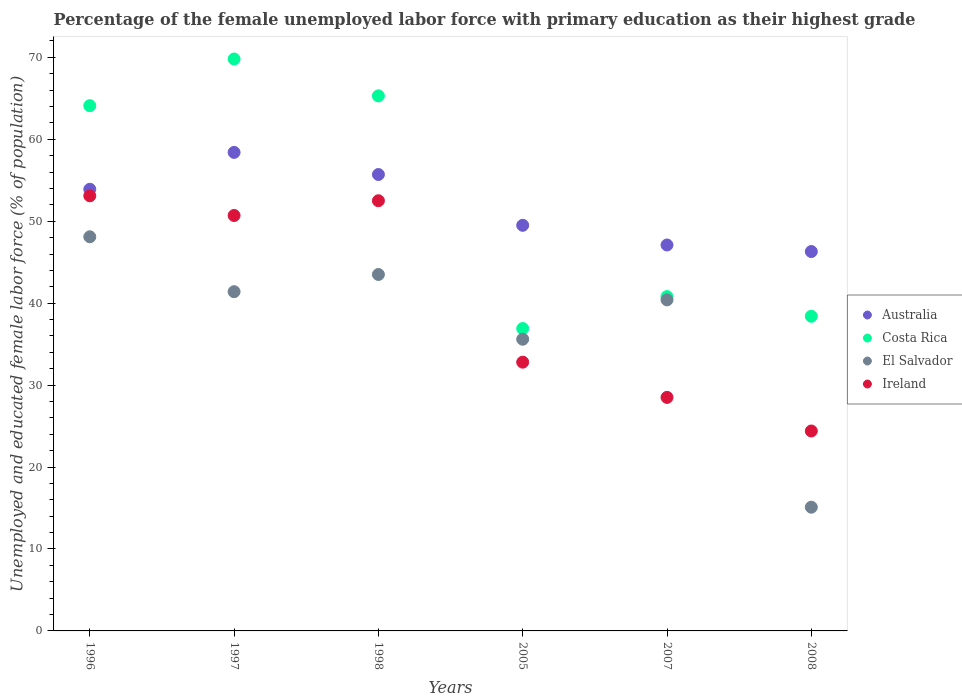How many different coloured dotlines are there?
Your response must be concise. 4. Is the number of dotlines equal to the number of legend labels?
Ensure brevity in your answer.  Yes. What is the percentage of the unemployed female labor force with primary education in El Salvador in 1997?
Your response must be concise. 41.4. Across all years, what is the maximum percentage of the unemployed female labor force with primary education in Costa Rica?
Keep it short and to the point. 69.8. Across all years, what is the minimum percentage of the unemployed female labor force with primary education in Ireland?
Your response must be concise. 24.4. In which year was the percentage of the unemployed female labor force with primary education in Costa Rica maximum?
Make the answer very short. 1997. What is the total percentage of the unemployed female labor force with primary education in Australia in the graph?
Your response must be concise. 310.9. What is the difference between the percentage of the unemployed female labor force with primary education in Ireland in 1997 and that in 2007?
Your answer should be very brief. 22.2. What is the difference between the percentage of the unemployed female labor force with primary education in Ireland in 1997 and the percentage of the unemployed female labor force with primary education in El Salvador in 2007?
Your answer should be very brief. 10.3. What is the average percentage of the unemployed female labor force with primary education in El Salvador per year?
Provide a succinct answer. 37.35. In the year 1997, what is the difference between the percentage of the unemployed female labor force with primary education in Ireland and percentage of the unemployed female labor force with primary education in Costa Rica?
Your answer should be compact. -19.1. In how many years, is the percentage of the unemployed female labor force with primary education in Australia greater than 32 %?
Give a very brief answer. 6. What is the ratio of the percentage of the unemployed female labor force with primary education in Ireland in 2007 to that in 2008?
Your answer should be compact. 1.17. Is the difference between the percentage of the unemployed female labor force with primary education in Ireland in 1998 and 2005 greater than the difference between the percentage of the unemployed female labor force with primary education in Costa Rica in 1998 and 2005?
Ensure brevity in your answer.  No. What is the difference between the highest and the second highest percentage of the unemployed female labor force with primary education in Australia?
Ensure brevity in your answer.  2.7. What is the difference between the highest and the lowest percentage of the unemployed female labor force with primary education in Australia?
Provide a succinct answer. 12.1. In how many years, is the percentage of the unemployed female labor force with primary education in Ireland greater than the average percentage of the unemployed female labor force with primary education in Ireland taken over all years?
Provide a succinct answer. 3. Is the sum of the percentage of the unemployed female labor force with primary education in Australia in 1996 and 1997 greater than the maximum percentage of the unemployed female labor force with primary education in Costa Rica across all years?
Make the answer very short. Yes. Is it the case that in every year, the sum of the percentage of the unemployed female labor force with primary education in Australia and percentage of the unemployed female labor force with primary education in El Salvador  is greater than the sum of percentage of the unemployed female labor force with primary education in Ireland and percentage of the unemployed female labor force with primary education in Costa Rica?
Your answer should be compact. No. Is it the case that in every year, the sum of the percentage of the unemployed female labor force with primary education in El Salvador and percentage of the unemployed female labor force with primary education in Australia  is greater than the percentage of the unemployed female labor force with primary education in Costa Rica?
Offer a terse response. Yes. Is the percentage of the unemployed female labor force with primary education in Australia strictly less than the percentage of the unemployed female labor force with primary education in Ireland over the years?
Give a very brief answer. No. How many years are there in the graph?
Give a very brief answer. 6. Are the values on the major ticks of Y-axis written in scientific E-notation?
Provide a succinct answer. No. How are the legend labels stacked?
Make the answer very short. Vertical. What is the title of the graph?
Keep it short and to the point. Percentage of the female unemployed labor force with primary education as their highest grade. Does "Sao Tome and Principe" appear as one of the legend labels in the graph?
Ensure brevity in your answer.  No. What is the label or title of the Y-axis?
Your answer should be compact. Unemployed and educated female labor force (% of population). What is the Unemployed and educated female labor force (% of population) of Australia in 1996?
Your response must be concise. 53.9. What is the Unemployed and educated female labor force (% of population) in Costa Rica in 1996?
Offer a terse response. 64.1. What is the Unemployed and educated female labor force (% of population) in El Salvador in 1996?
Keep it short and to the point. 48.1. What is the Unemployed and educated female labor force (% of population) of Ireland in 1996?
Ensure brevity in your answer.  53.1. What is the Unemployed and educated female labor force (% of population) of Australia in 1997?
Offer a very short reply. 58.4. What is the Unemployed and educated female labor force (% of population) of Costa Rica in 1997?
Offer a very short reply. 69.8. What is the Unemployed and educated female labor force (% of population) of El Salvador in 1997?
Ensure brevity in your answer.  41.4. What is the Unemployed and educated female labor force (% of population) in Ireland in 1997?
Make the answer very short. 50.7. What is the Unemployed and educated female labor force (% of population) of Australia in 1998?
Keep it short and to the point. 55.7. What is the Unemployed and educated female labor force (% of population) in Costa Rica in 1998?
Offer a terse response. 65.3. What is the Unemployed and educated female labor force (% of population) of El Salvador in 1998?
Offer a terse response. 43.5. What is the Unemployed and educated female labor force (% of population) in Ireland in 1998?
Make the answer very short. 52.5. What is the Unemployed and educated female labor force (% of population) of Australia in 2005?
Your answer should be very brief. 49.5. What is the Unemployed and educated female labor force (% of population) of Costa Rica in 2005?
Offer a terse response. 36.9. What is the Unemployed and educated female labor force (% of population) of El Salvador in 2005?
Provide a short and direct response. 35.6. What is the Unemployed and educated female labor force (% of population) in Ireland in 2005?
Give a very brief answer. 32.8. What is the Unemployed and educated female labor force (% of population) of Australia in 2007?
Make the answer very short. 47.1. What is the Unemployed and educated female labor force (% of population) in Costa Rica in 2007?
Your answer should be very brief. 40.8. What is the Unemployed and educated female labor force (% of population) in El Salvador in 2007?
Provide a succinct answer. 40.4. What is the Unemployed and educated female labor force (% of population) in Ireland in 2007?
Your response must be concise. 28.5. What is the Unemployed and educated female labor force (% of population) in Australia in 2008?
Give a very brief answer. 46.3. What is the Unemployed and educated female labor force (% of population) in Costa Rica in 2008?
Provide a short and direct response. 38.4. What is the Unemployed and educated female labor force (% of population) of El Salvador in 2008?
Your answer should be very brief. 15.1. What is the Unemployed and educated female labor force (% of population) in Ireland in 2008?
Your answer should be compact. 24.4. Across all years, what is the maximum Unemployed and educated female labor force (% of population) in Australia?
Your answer should be compact. 58.4. Across all years, what is the maximum Unemployed and educated female labor force (% of population) in Costa Rica?
Your response must be concise. 69.8. Across all years, what is the maximum Unemployed and educated female labor force (% of population) in El Salvador?
Make the answer very short. 48.1. Across all years, what is the maximum Unemployed and educated female labor force (% of population) in Ireland?
Your answer should be very brief. 53.1. Across all years, what is the minimum Unemployed and educated female labor force (% of population) of Australia?
Give a very brief answer. 46.3. Across all years, what is the minimum Unemployed and educated female labor force (% of population) of Costa Rica?
Provide a short and direct response. 36.9. Across all years, what is the minimum Unemployed and educated female labor force (% of population) of El Salvador?
Your response must be concise. 15.1. Across all years, what is the minimum Unemployed and educated female labor force (% of population) of Ireland?
Ensure brevity in your answer.  24.4. What is the total Unemployed and educated female labor force (% of population) in Australia in the graph?
Your response must be concise. 310.9. What is the total Unemployed and educated female labor force (% of population) in Costa Rica in the graph?
Keep it short and to the point. 315.3. What is the total Unemployed and educated female labor force (% of population) of El Salvador in the graph?
Provide a short and direct response. 224.1. What is the total Unemployed and educated female labor force (% of population) in Ireland in the graph?
Ensure brevity in your answer.  242. What is the difference between the Unemployed and educated female labor force (% of population) in Costa Rica in 1996 and that in 1997?
Your response must be concise. -5.7. What is the difference between the Unemployed and educated female labor force (% of population) of El Salvador in 1996 and that in 1997?
Offer a very short reply. 6.7. What is the difference between the Unemployed and educated female labor force (% of population) of Ireland in 1996 and that in 1997?
Provide a short and direct response. 2.4. What is the difference between the Unemployed and educated female labor force (% of population) in Costa Rica in 1996 and that in 2005?
Keep it short and to the point. 27.2. What is the difference between the Unemployed and educated female labor force (% of population) in El Salvador in 1996 and that in 2005?
Keep it short and to the point. 12.5. What is the difference between the Unemployed and educated female labor force (% of population) in Ireland in 1996 and that in 2005?
Your answer should be very brief. 20.3. What is the difference between the Unemployed and educated female labor force (% of population) of Australia in 1996 and that in 2007?
Ensure brevity in your answer.  6.8. What is the difference between the Unemployed and educated female labor force (% of population) in Costa Rica in 1996 and that in 2007?
Provide a short and direct response. 23.3. What is the difference between the Unemployed and educated female labor force (% of population) in El Salvador in 1996 and that in 2007?
Ensure brevity in your answer.  7.7. What is the difference between the Unemployed and educated female labor force (% of population) in Ireland in 1996 and that in 2007?
Your answer should be very brief. 24.6. What is the difference between the Unemployed and educated female labor force (% of population) of Costa Rica in 1996 and that in 2008?
Offer a terse response. 25.7. What is the difference between the Unemployed and educated female labor force (% of population) in El Salvador in 1996 and that in 2008?
Ensure brevity in your answer.  33. What is the difference between the Unemployed and educated female labor force (% of population) of Ireland in 1996 and that in 2008?
Keep it short and to the point. 28.7. What is the difference between the Unemployed and educated female labor force (% of population) in Costa Rica in 1997 and that in 1998?
Offer a terse response. 4.5. What is the difference between the Unemployed and educated female labor force (% of population) in El Salvador in 1997 and that in 1998?
Make the answer very short. -2.1. What is the difference between the Unemployed and educated female labor force (% of population) in Costa Rica in 1997 and that in 2005?
Offer a terse response. 32.9. What is the difference between the Unemployed and educated female labor force (% of population) in El Salvador in 1997 and that in 2005?
Provide a short and direct response. 5.8. What is the difference between the Unemployed and educated female labor force (% of population) of Ireland in 1997 and that in 2005?
Offer a terse response. 17.9. What is the difference between the Unemployed and educated female labor force (% of population) in Australia in 1997 and that in 2007?
Ensure brevity in your answer.  11.3. What is the difference between the Unemployed and educated female labor force (% of population) in Costa Rica in 1997 and that in 2007?
Your answer should be compact. 29. What is the difference between the Unemployed and educated female labor force (% of population) in El Salvador in 1997 and that in 2007?
Provide a short and direct response. 1. What is the difference between the Unemployed and educated female labor force (% of population) in Ireland in 1997 and that in 2007?
Your answer should be compact. 22.2. What is the difference between the Unemployed and educated female labor force (% of population) of Costa Rica in 1997 and that in 2008?
Keep it short and to the point. 31.4. What is the difference between the Unemployed and educated female labor force (% of population) of El Salvador in 1997 and that in 2008?
Offer a terse response. 26.3. What is the difference between the Unemployed and educated female labor force (% of population) in Ireland in 1997 and that in 2008?
Ensure brevity in your answer.  26.3. What is the difference between the Unemployed and educated female labor force (% of population) of Australia in 1998 and that in 2005?
Your answer should be compact. 6.2. What is the difference between the Unemployed and educated female labor force (% of population) of Costa Rica in 1998 and that in 2005?
Your answer should be very brief. 28.4. What is the difference between the Unemployed and educated female labor force (% of population) in Australia in 1998 and that in 2007?
Keep it short and to the point. 8.6. What is the difference between the Unemployed and educated female labor force (% of population) in El Salvador in 1998 and that in 2007?
Ensure brevity in your answer.  3.1. What is the difference between the Unemployed and educated female labor force (% of population) in Ireland in 1998 and that in 2007?
Make the answer very short. 24. What is the difference between the Unemployed and educated female labor force (% of population) of Costa Rica in 1998 and that in 2008?
Offer a terse response. 26.9. What is the difference between the Unemployed and educated female labor force (% of population) of El Salvador in 1998 and that in 2008?
Provide a short and direct response. 28.4. What is the difference between the Unemployed and educated female labor force (% of population) in Ireland in 1998 and that in 2008?
Ensure brevity in your answer.  28.1. What is the difference between the Unemployed and educated female labor force (% of population) in Australia in 2005 and that in 2007?
Make the answer very short. 2.4. What is the difference between the Unemployed and educated female labor force (% of population) in Australia in 2005 and that in 2008?
Offer a terse response. 3.2. What is the difference between the Unemployed and educated female labor force (% of population) in Costa Rica in 2005 and that in 2008?
Offer a terse response. -1.5. What is the difference between the Unemployed and educated female labor force (% of population) of El Salvador in 2005 and that in 2008?
Offer a terse response. 20.5. What is the difference between the Unemployed and educated female labor force (% of population) of El Salvador in 2007 and that in 2008?
Your response must be concise. 25.3. What is the difference between the Unemployed and educated female labor force (% of population) in Ireland in 2007 and that in 2008?
Your response must be concise. 4.1. What is the difference between the Unemployed and educated female labor force (% of population) of Australia in 1996 and the Unemployed and educated female labor force (% of population) of Costa Rica in 1997?
Provide a succinct answer. -15.9. What is the difference between the Unemployed and educated female labor force (% of population) in Australia in 1996 and the Unemployed and educated female labor force (% of population) in El Salvador in 1997?
Keep it short and to the point. 12.5. What is the difference between the Unemployed and educated female labor force (% of population) in Australia in 1996 and the Unemployed and educated female labor force (% of population) in Ireland in 1997?
Give a very brief answer. 3.2. What is the difference between the Unemployed and educated female labor force (% of population) in Costa Rica in 1996 and the Unemployed and educated female labor force (% of population) in El Salvador in 1997?
Give a very brief answer. 22.7. What is the difference between the Unemployed and educated female labor force (% of population) in Costa Rica in 1996 and the Unemployed and educated female labor force (% of population) in Ireland in 1997?
Make the answer very short. 13.4. What is the difference between the Unemployed and educated female labor force (% of population) in Australia in 1996 and the Unemployed and educated female labor force (% of population) in Costa Rica in 1998?
Keep it short and to the point. -11.4. What is the difference between the Unemployed and educated female labor force (% of population) in Australia in 1996 and the Unemployed and educated female labor force (% of population) in El Salvador in 1998?
Your response must be concise. 10.4. What is the difference between the Unemployed and educated female labor force (% of population) in Australia in 1996 and the Unemployed and educated female labor force (% of population) in Ireland in 1998?
Your answer should be very brief. 1.4. What is the difference between the Unemployed and educated female labor force (% of population) in Costa Rica in 1996 and the Unemployed and educated female labor force (% of population) in El Salvador in 1998?
Ensure brevity in your answer.  20.6. What is the difference between the Unemployed and educated female labor force (% of population) of Costa Rica in 1996 and the Unemployed and educated female labor force (% of population) of Ireland in 1998?
Offer a terse response. 11.6. What is the difference between the Unemployed and educated female labor force (% of population) in Australia in 1996 and the Unemployed and educated female labor force (% of population) in Ireland in 2005?
Give a very brief answer. 21.1. What is the difference between the Unemployed and educated female labor force (% of population) of Costa Rica in 1996 and the Unemployed and educated female labor force (% of population) of El Salvador in 2005?
Your answer should be compact. 28.5. What is the difference between the Unemployed and educated female labor force (% of population) in Costa Rica in 1996 and the Unemployed and educated female labor force (% of population) in Ireland in 2005?
Keep it short and to the point. 31.3. What is the difference between the Unemployed and educated female labor force (% of population) in Australia in 1996 and the Unemployed and educated female labor force (% of population) in El Salvador in 2007?
Provide a short and direct response. 13.5. What is the difference between the Unemployed and educated female labor force (% of population) of Australia in 1996 and the Unemployed and educated female labor force (% of population) of Ireland in 2007?
Ensure brevity in your answer.  25.4. What is the difference between the Unemployed and educated female labor force (% of population) in Costa Rica in 1996 and the Unemployed and educated female labor force (% of population) in El Salvador in 2007?
Provide a succinct answer. 23.7. What is the difference between the Unemployed and educated female labor force (% of population) in Costa Rica in 1996 and the Unemployed and educated female labor force (% of population) in Ireland in 2007?
Keep it short and to the point. 35.6. What is the difference between the Unemployed and educated female labor force (% of population) in El Salvador in 1996 and the Unemployed and educated female labor force (% of population) in Ireland in 2007?
Offer a terse response. 19.6. What is the difference between the Unemployed and educated female labor force (% of population) of Australia in 1996 and the Unemployed and educated female labor force (% of population) of El Salvador in 2008?
Your answer should be compact. 38.8. What is the difference between the Unemployed and educated female labor force (% of population) in Australia in 1996 and the Unemployed and educated female labor force (% of population) in Ireland in 2008?
Your answer should be compact. 29.5. What is the difference between the Unemployed and educated female labor force (% of population) of Costa Rica in 1996 and the Unemployed and educated female labor force (% of population) of El Salvador in 2008?
Offer a terse response. 49. What is the difference between the Unemployed and educated female labor force (% of population) of Costa Rica in 1996 and the Unemployed and educated female labor force (% of population) of Ireland in 2008?
Provide a succinct answer. 39.7. What is the difference between the Unemployed and educated female labor force (% of population) in El Salvador in 1996 and the Unemployed and educated female labor force (% of population) in Ireland in 2008?
Offer a very short reply. 23.7. What is the difference between the Unemployed and educated female labor force (% of population) in Australia in 1997 and the Unemployed and educated female labor force (% of population) in Costa Rica in 1998?
Ensure brevity in your answer.  -6.9. What is the difference between the Unemployed and educated female labor force (% of population) of Costa Rica in 1997 and the Unemployed and educated female labor force (% of population) of El Salvador in 1998?
Your answer should be very brief. 26.3. What is the difference between the Unemployed and educated female labor force (% of population) of Australia in 1997 and the Unemployed and educated female labor force (% of population) of El Salvador in 2005?
Give a very brief answer. 22.8. What is the difference between the Unemployed and educated female labor force (% of population) in Australia in 1997 and the Unemployed and educated female labor force (% of population) in Ireland in 2005?
Give a very brief answer. 25.6. What is the difference between the Unemployed and educated female labor force (% of population) of Costa Rica in 1997 and the Unemployed and educated female labor force (% of population) of El Salvador in 2005?
Your answer should be very brief. 34.2. What is the difference between the Unemployed and educated female labor force (% of population) in Australia in 1997 and the Unemployed and educated female labor force (% of population) in Ireland in 2007?
Give a very brief answer. 29.9. What is the difference between the Unemployed and educated female labor force (% of population) of Costa Rica in 1997 and the Unemployed and educated female labor force (% of population) of El Salvador in 2007?
Provide a short and direct response. 29.4. What is the difference between the Unemployed and educated female labor force (% of population) of Costa Rica in 1997 and the Unemployed and educated female labor force (% of population) of Ireland in 2007?
Your response must be concise. 41.3. What is the difference between the Unemployed and educated female labor force (% of population) in Australia in 1997 and the Unemployed and educated female labor force (% of population) in Costa Rica in 2008?
Offer a very short reply. 20. What is the difference between the Unemployed and educated female labor force (% of population) of Australia in 1997 and the Unemployed and educated female labor force (% of population) of El Salvador in 2008?
Give a very brief answer. 43.3. What is the difference between the Unemployed and educated female labor force (% of population) in Costa Rica in 1997 and the Unemployed and educated female labor force (% of population) in El Salvador in 2008?
Your answer should be very brief. 54.7. What is the difference between the Unemployed and educated female labor force (% of population) of Costa Rica in 1997 and the Unemployed and educated female labor force (% of population) of Ireland in 2008?
Offer a very short reply. 45.4. What is the difference between the Unemployed and educated female labor force (% of population) in El Salvador in 1997 and the Unemployed and educated female labor force (% of population) in Ireland in 2008?
Give a very brief answer. 17. What is the difference between the Unemployed and educated female labor force (% of population) of Australia in 1998 and the Unemployed and educated female labor force (% of population) of El Salvador in 2005?
Keep it short and to the point. 20.1. What is the difference between the Unemployed and educated female labor force (% of population) of Australia in 1998 and the Unemployed and educated female labor force (% of population) of Ireland in 2005?
Make the answer very short. 22.9. What is the difference between the Unemployed and educated female labor force (% of population) in Costa Rica in 1998 and the Unemployed and educated female labor force (% of population) in El Salvador in 2005?
Give a very brief answer. 29.7. What is the difference between the Unemployed and educated female labor force (% of population) in Costa Rica in 1998 and the Unemployed and educated female labor force (% of population) in Ireland in 2005?
Provide a succinct answer. 32.5. What is the difference between the Unemployed and educated female labor force (% of population) of Australia in 1998 and the Unemployed and educated female labor force (% of population) of El Salvador in 2007?
Your response must be concise. 15.3. What is the difference between the Unemployed and educated female labor force (% of population) of Australia in 1998 and the Unemployed and educated female labor force (% of population) of Ireland in 2007?
Your response must be concise. 27.2. What is the difference between the Unemployed and educated female labor force (% of population) of Costa Rica in 1998 and the Unemployed and educated female labor force (% of population) of El Salvador in 2007?
Your response must be concise. 24.9. What is the difference between the Unemployed and educated female labor force (% of population) of Costa Rica in 1998 and the Unemployed and educated female labor force (% of population) of Ireland in 2007?
Give a very brief answer. 36.8. What is the difference between the Unemployed and educated female labor force (% of population) of Australia in 1998 and the Unemployed and educated female labor force (% of population) of Costa Rica in 2008?
Your answer should be compact. 17.3. What is the difference between the Unemployed and educated female labor force (% of population) in Australia in 1998 and the Unemployed and educated female labor force (% of population) in El Salvador in 2008?
Provide a short and direct response. 40.6. What is the difference between the Unemployed and educated female labor force (% of population) in Australia in 1998 and the Unemployed and educated female labor force (% of population) in Ireland in 2008?
Provide a short and direct response. 31.3. What is the difference between the Unemployed and educated female labor force (% of population) in Costa Rica in 1998 and the Unemployed and educated female labor force (% of population) in El Salvador in 2008?
Provide a short and direct response. 50.2. What is the difference between the Unemployed and educated female labor force (% of population) of Costa Rica in 1998 and the Unemployed and educated female labor force (% of population) of Ireland in 2008?
Your answer should be compact. 40.9. What is the difference between the Unemployed and educated female labor force (% of population) of El Salvador in 1998 and the Unemployed and educated female labor force (% of population) of Ireland in 2008?
Make the answer very short. 19.1. What is the difference between the Unemployed and educated female labor force (% of population) in Costa Rica in 2005 and the Unemployed and educated female labor force (% of population) in El Salvador in 2007?
Your response must be concise. -3.5. What is the difference between the Unemployed and educated female labor force (% of population) of Costa Rica in 2005 and the Unemployed and educated female labor force (% of population) of Ireland in 2007?
Give a very brief answer. 8.4. What is the difference between the Unemployed and educated female labor force (% of population) in Australia in 2005 and the Unemployed and educated female labor force (% of population) in El Salvador in 2008?
Your answer should be compact. 34.4. What is the difference between the Unemployed and educated female labor force (% of population) of Australia in 2005 and the Unemployed and educated female labor force (% of population) of Ireland in 2008?
Provide a succinct answer. 25.1. What is the difference between the Unemployed and educated female labor force (% of population) of Costa Rica in 2005 and the Unemployed and educated female labor force (% of population) of El Salvador in 2008?
Your answer should be very brief. 21.8. What is the difference between the Unemployed and educated female labor force (% of population) of El Salvador in 2005 and the Unemployed and educated female labor force (% of population) of Ireland in 2008?
Offer a terse response. 11.2. What is the difference between the Unemployed and educated female labor force (% of population) in Australia in 2007 and the Unemployed and educated female labor force (% of population) in El Salvador in 2008?
Your answer should be compact. 32. What is the difference between the Unemployed and educated female labor force (% of population) of Australia in 2007 and the Unemployed and educated female labor force (% of population) of Ireland in 2008?
Ensure brevity in your answer.  22.7. What is the difference between the Unemployed and educated female labor force (% of population) in Costa Rica in 2007 and the Unemployed and educated female labor force (% of population) in El Salvador in 2008?
Offer a terse response. 25.7. What is the difference between the Unemployed and educated female labor force (% of population) of Costa Rica in 2007 and the Unemployed and educated female labor force (% of population) of Ireland in 2008?
Keep it short and to the point. 16.4. What is the average Unemployed and educated female labor force (% of population) in Australia per year?
Provide a short and direct response. 51.82. What is the average Unemployed and educated female labor force (% of population) in Costa Rica per year?
Offer a very short reply. 52.55. What is the average Unemployed and educated female labor force (% of population) in El Salvador per year?
Give a very brief answer. 37.35. What is the average Unemployed and educated female labor force (% of population) of Ireland per year?
Ensure brevity in your answer.  40.33. In the year 1996, what is the difference between the Unemployed and educated female labor force (% of population) in Australia and Unemployed and educated female labor force (% of population) in Costa Rica?
Give a very brief answer. -10.2. In the year 1996, what is the difference between the Unemployed and educated female labor force (% of population) of Australia and Unemployed and educated female labor force (% of population) of Ireland?
Provide a succinct answer. 0.8. In the year 1996, what is the difference between the Unemployed and educated female labor force (% of population) of Costa Rica and Unemployed and educated female labor force (% of population) of Ireland?
Offer a terse response. 11. In the year 1997, what is the difference between the Unemployed and educated female labor force (% of population) in Australia and Unemployed and educated female labor force (% of population) in Costa Rica?
Provide a succinct answer. -11.4. In the year 1997, what is the difference between the Unemployed and educated female labor force (% of population) of Australia and Unemployed and educated female labor force (% of population) of El Salvador?
Make the answer very short. 17. In the year 1997, what is the difference between the Unemployed and educated female labor force (% of population) of Australia and Unemployed and educated female labor force (% of population) of Ireland?
Offer a terse response. 7.7. In the year 1997, what is the difference between the Unemployed and educated female labor force (% of population) of Costa Rica and Unemployed and educated female labor force (% of population) of El Salvador?
Offer a terse response. 28.4. In the year 1997, what is the difference between the Unemployed and educated female labor force (% of population) in Costa Rica and Unemployed and educated female labor force (% of population) in Ireland?
Your response must be concise. 19.1. In the year 1997, what is the difference between the Unemployed and educated female labor force (% of population) of El Salvador and Unemployed and educated female labor force (% of population) of Ireland?
Keep it short and to the point. -9.3. In the year 1998, what is the difference between the Unemployed and educated female labor force (% of population) in Australia and Unemployed and educated female labor force (% of population) in El Salvador?
Keep it short and to the point. 12.2. In the year 1998, what is the difference between the Unemployed and educated female labor force (% of population) in Australia and Unemployed and educated female labor force (% of population) in Ireland?
Provide a succinct answer. 3.2. In the year 1998, what is the difference between the Unemployed and educated female labor force (% of population) of Costa Rica and Unemployed and educated female labor force (% of population) of El Salvador?
Give a very brief answer. 21.8. In the year 2005, what is the difference between the Unemployed and educated female labor force (% of population) in Australia and Unemployed and educated female labor force (% of population) in El Salvador?
Your response must be concise. 13.9. In the year 2005, what is the difference between the Unemployed and educated female labor force (% of population) in Australia and Unemployed and educated female labor force (% of population) in Ireland?
Your response must be concise. 16.7. In the year 2005, what is the difference between the Unemployed and educated female labor force (% of population) in Costa Rica and Unemployed and educated female labor force (% of population) in El Salvador?
Your answer should be very brief. 1.3. In the year 2005, what is the difference between the Unemployed and educated female labor force (% of population) in El Salvador and Unemployed and educated female labor force (% of population) in Ireland?
Give a very brief answer. 2.8. In the year 2007, what is the difference between the Unemployed and educated female labor force (% of population) in Australia and Unemployed and educated female labor force (% of population) in Costa Rica?
Offer a terse response. 6.3. In the year 2007, what is the difference between the Unemployed and educated female labor force (% of population) in Australia and Unemployed and educated female labor force (% of population) in El Salvador?
Provide a short and direct response. 6.7. In the year 2007, what is the difference between the Unemployed and educated female labor force (% of population) of Costa Rica and Unemployed and educated female labor force (% of population) of El Salvador?
Ensure brevity in your answer.  0.4. In the year 2007, what is the difference between the Unemployed and educated female labor force (% of population) in Costa Rica and Unemployed and educated female labor force (% of population) in Ireland?
Keep it short and to the point. 12.3. In the year 2008, what is the difference between the Unemployed and educated female labor force (% of population) in Australia and Unemployed and educated female labor force (% of population) in Costa Rica?
Your answer should be compact. 7.9. In the year 2008, what is the difference between the Unemployed and educated female labor force (% of population) of Australia and Unemployed and educated female labor force (% of population) of El Salvador?
Provide a short and direct response. 31.2. In the year 2008, what is the difference between the Unemployed and educated female labor force (% of population) in Australia and Unemployed and educated female labor force (% of population) in Ireland?
Offer a terse response. 21.9. In the year 2008, what is the difference between the Unemployed and educated female labor force (% of population) in Costa Rica and Unemployed and educated female labor force (% of population) in El Salvador?
Offer a very short reply. 23.3. In the year 2008, what is the difference between the Unemployed and educated female labor force (% of population) of Costa Rica and Unemployed and educated female labor force (% of population) of Ireland?
Keep it short and to the point. 14. What is the ratio of the Unemployed and educated female labor force (% of population) of Australia in 1996 to that in 1997?
Your answer should be compact. 0.92. What is the ratio of the Unemployed and educated female labor force (% of population) of Costa Rica in 1996 to that in 1997?
Your answer should be compact. 0.92. What is the ratio of the Unemployed and educated female labor force (% of population) in El Salvador in 1996 to that in 1997?
Provide a short and direct response. 1.16. What is the ratio of the Unemployed and educated female labor force (% of population) of Ireland in 1996 to that in 1997?
Your answer should be very brief. 1.05. What is the ratio of the Unemployed and educated female labor force (% of population) in Costa Rica in 1996 to that in 1998?
Your answer should be very brief. 0.98. What is the ratio of the Unemployed and educated female labor force (% of population) in El Salvador in 1996 to that in 1998?
Offer a very short reply. 1.11. What is the ratio of the Unemployed and educated female labor force (% of population) in Ireland in 1996 to that in 1998?
Provide a short and direct response. 1.01. What is the ratio of the Unemployed and educated female labor force (% of population) in Australia in 1996 to that in 2005?
Provide a short and direct response. 1.09. What is the ratio of the Unemployed and educated female labor force (% of population) of Costa Rica in 1996 to that in 2005?
Ensure brevity in your answer.  1.74. What is the ratio of the Unemployed and educated female labor force (% of population) in El Salvador in 1996 to that in 2005?
Provide a succinct answer. 1.35. What is the ratio of the Unemployed and educated female labor force (% of population) of Ireland in 1996 to that in 2005?
Keep it short and to the point. 1.62. What is the ratio of the Unemployed and educated female labor force (% of population) in Australia in 1996 to that in 2007?
Offer a terse response. 1.14. What is the ratio of the Unemployed and educated female labor force (% of population) of Costa Rica in 1996 to that in 2007?
Your answer should be compact. 1.57. What is the ratio of the Unemployed and educated female labor force (% of population) in El Salvador in 1996 to that in 2007?
Offer a very short reply. 1.19. What is the ratio of the Unemployed and educated female labor force (% of population) in Ireland in 1996 to that in 2007?
Your answer should be compact. 1.86. What is the ratio of the Unemployed and educated female labor force (% of population) in Australia in 1996 to that in 2008?
Make the answer very short. 1.16. What is the ratio of the Unemployed and educated female labor force (% of population) in Costa Rica in 1996 to that in 2008?
Make the answer very short. 1.67. What is the ratio of the Unemployed and educated female labor force (% of population) in El Salvador in 1996 to that in 2008?
Your answer should be compact. 3.19. What is the ratio of the Unemployed and educated female labor force (% of population) in Ireland in 1996 to that in 2008?
Ensure brevity in your answer.  2.18. What is the ratio of the Unemployed and educated female labor force (% of population) of Australia in 1997 to that in 1998?
Provide a succinct answer. 1.05. What is the ratio of the Unemployed and educated female labor force (% of population) in Costa Rica in 1997 to that in 1998?
Make the answer very short. 1.07. What is the ratio of the Unemployed and educated female labor force (% of population) in El Salvador in 1997 to that in 1998?
Provide a succinct answer. 0.95. What is the ratio of the Unemployed and educated female labor force (% of population) of Ireland in 1997 to that in 1998?
Ensure brevity in your answer.  0.97. What is the ratio of the Unemployed and educated female labor force (% of population) of Australia in 1997 to that in 2005?
Your response must be concise. 1.18. What is the ratio of the Unemployed and educated female labor force (% of population) in Costa Rica in 1997 to that in 2005?
Your answer should be very brief. 1.89. What is the ratio of the Unemployed and educated female labor force (% of population) in El Salvador in 1997 to that in 2005?
Your response must be concise. 1.16. What is the ratio of the Unemployed and educated female labor force (% of population) of Ireland in 1997 to that in 2005?
Make the answer very short. 1.55. What is the ratio of the Unemployed and educated female labor force (% of population) of Australia in 1997 to that in 2007?
Keep it short and to the point. 1.24. What is the ratio of the Unemployed and educated female labor force (% of population) of Costa Rica in 1997 to that in 2007?
Your response must be concise. 1.71. What is the ratio of the Unemployed and educated female labor force (% of population) in El Salvador in 1997 to that in 2007?
Provide a short and direct response. 1.02. What is the ratio of the Unemployed and educated female labor force (% of population) of Ireland in 1997 to that in 2007?
Keep it short and to the point. 1.78. What is the ratio of the Unemployed and educated female labor force (% of population) of Australia in 1997 to that in 2008?
Provide a succinct answer. 1.26. What is the ratio of the Unemployed and educated female labor force (% of population) of Costa Rica in 1997 to that in 2008?
Make the answer very short. 1.82. What is the ratio of the Unemployed and educated female labor force (% of population) of El Salvador in 1997 to that in 2008?
Keep it short and to the point. 2.74. What is the ratio of the Unemployed and educated female labor force (% of population) of Ireland in 1997 to that in 2008?
Your response must be concise. 2.08. What is the ratio of the Unemployed and educated female labor force (% of population) of Australia in 1998 to that in 2005?
Provide a succinct answer. 1.13. What is the ratio of the Unemployed and educated female labor force (% of population) of Costa Rica in 1998 to that in 2005?
Make the answer very short. 1.77. What is the ratio of the Unemployed and educated female labor force (% of population) of El Salvador in 1998 to that in 2005?
Offer a terse response. 1.22. What is the ratio of the Unemployed and educated female labor force (% of population) in Ireland in 1998 to that in 2005?
Keep it short and to the point. 1.6. What is the ratio of the Unemployed and educated female labor force (% of population) in Australia in 1998 to that in 2007?
Your answer should be very brief. 1.18. What is the ratio of the Unemployed and educated female labor force (% of population) in Costa Rica in 1998 to that in 2007?
Your response must be concise. 1.6. What is the ratio of the Unemployed and educated female labor force (% of population) of El Salvador in 1998 to that in 2007?
Provide a short and direct response. 1.08. What is the ratio of the Unemployed and educated female labor force (% of population) of Ireland in 1998 to that in 2007?
Your response must be concise. 1.84. What is the ratio of the Unemployed and educated female labor force (% of population) in Australia in 1998 to that in 2008?
Your answer should be very brief. 1.2. What is the ratio of the Unemployed and educated female labor force (% of population) of Costa Rica in 1998 to that in 2008?
Give a very brief answer. 1.7. What is the ratio of the Unemployed and educated female labor force (% of population) in El Salvador in 1998 to that in 2008?
Ensure brevity in your answer.  2.88. What is the ratio of the Unemployed and educated female labor force (% of population) of Ireland in 1998 to that in 2008?
Provide a succinct answer. 2.15. What is the ratio of the Unemployed and educated female labor force (% of population) in Australia in 2005 to that in 2007?
Keep it short and to the point. 1.05. What is the ratio of the Unemployed and educated female labor force (% of population) of Costa Rica in 2005 to that in 2007?
Give a very brief answer. 0.9. What is the ratio of the Unemployed and educated female labor force (% of population) of El Salvador in 2005 to that in 2007?
Offer a very short reply. 0.88. What is the ratio of the Unemployed and educated female labor force (% of population) in Ireland in 2005 to that in 2007?
Offer a terse response. 1.15. What is the ratio of the Unemployed and educated female labor force (% of population) in Australia in 2005 to that in 2008?
Provide a short and direct response. 1.07. What is the ratio of the Unemployed and educated female labor force (% of population) in Costa Rica in 2005 to that in 2008?
Provide a short and direct response. 0.96. What is the ratio of the Unemployed and educated female labor force (% of population) in El Salvador in 2005 to that in 2008?
Offer a very short reply. 2.36. What is the ratio of the Unemployed and educated female labor force (% of population) of Ireland in 2005 to that in 2008?
Make the answer very short. 1.34. What is the ratio of the Unemployed and educated female labor force (% of population) of Australia in 2007 to that in 2008?
Make the answer very short. 1.02. What is the ratio of the Unemployed and educated female labor force (% of population) in Costa Rica in 2007 to that in 2008?
Offer a very short reply. 1.06. What is the ratio of the Unemployed and educated female labor force (% of population) in El Salvador in 2007 to that in 2008?
Your answer should be compact. 2.68. What is the ratio of the Unemployed and educated female labor force (% of population) in Ireland in 2007 to that in 2008?
Offer a terse response. 1.17. What is the difference between the highest and the second highest Unemployed and educated female labor force (% of population) in Australia?
Keep it short and to the point. 2.7. What is the difference between the highest and the second highest Unemployed and educated female labor force (% of population) of El Salvador?
Ensure brevity in your answer.  4.6. What is the difference between the highest and the second highest Unemployed and educated female labor force (% of population) of Ireland?
Provide a succinct answer. 0.6. What is the difference between the highest and the lowest Unemployed and educated female labor force (% of population) of Costa Rica?
Provide a succinct answer. 32.9. What is the difference between the highest and the lowest Unemployed and educated female labor force (% of population) of El Salvador?
Your answer should be compact. 33. What is the difference between the highest and the lowest Unemployed and educated female labor force (% of population) of Ireland?
Your answer should be very brief. 28.7. 